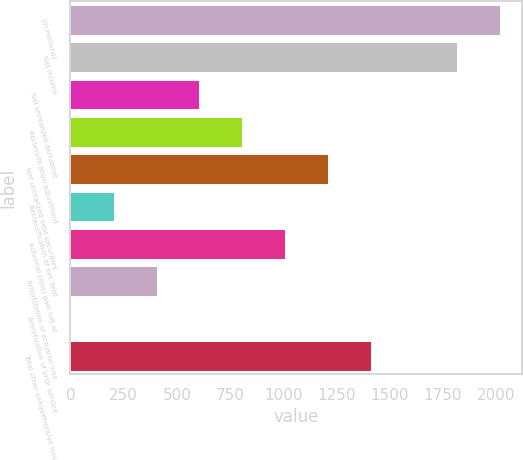<chart> <loc_0><loc_0><loc_500><loc_500><bar_chart><fcel>(in millions)<fcel>Net income<fcel>Net unrealized derivative<fcel>Reclassification adjustment<fcel>Net unrealized debt securities<fcel>Reclassification of net debt<fcel>Actuarial (loss) gain net of<fcel>Amortization of actuarial loss<fcel>Amortization of prior service<fcel>Total other comprehensive loss<nl><fcel>2018<fcel>1816.3<fcel>606.1<fcel>807.8<fcel>1211.2<fcel>202.7<fcel>1009.5<fcel>404.4<fcel>1<fcel>1412.9<nl></chart> 